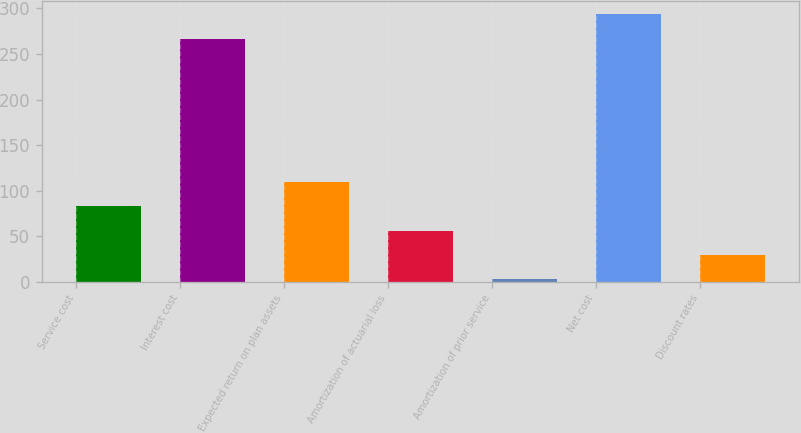Convert chart. <chart><loc_0><loc_0><loc_500><loc_500><bar_chart><fcel>Service cost<fcel>Interest cost<fcel>Expected return on plan assets<fcel>Amortization of actuarial loss<fcel>Amortization of prior service<fcel>Net cost<fcel>Discount rates<nl><fcel>82.5<fcel>267<fcel>109<fcel>56<fcel>3<fcel>293.5<fcel>29.5<nl></chart> 